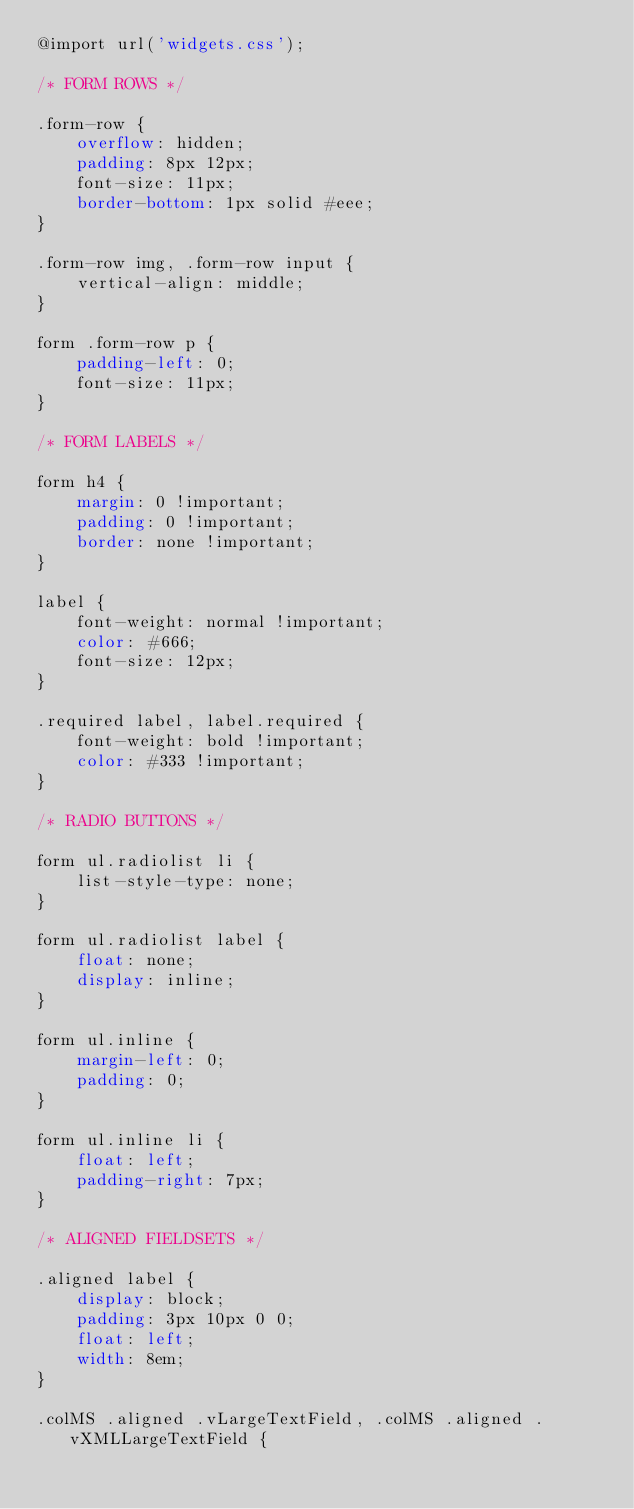Convert code to text. <code><loc_0><loc_0><loc_500><loc_500><_CSS_>@import url('widgets.css');

/* FORM ROWS */

.form-row {
    overflow: hidden;
    padding: 8px 12px;
    font-size: 11px;
    border-bottom: 1px solid #eee;
}

.form-row img, .form-row input {
    vertical-align: middle;
}

form .form-row p {
    padding-left: 0;
    font-size: 11px;
}

/* FORM LABELS */

form h4 {
    margin: 0 !important;
    padding: 0 !important;
    border: none !important;
}

label {
    font-weight: normal !important;
    color: #666;
    font-size: 12px;
}

.required label, label.required {
    font-weight: bold !important;
    color: #333 !important;
}

/* RADIO BUTTONS */

form ul.radiolist li {
    list-style-type: none;
}

form ul.radiolist label {
    float: none;
    display: inline;
}

form ul.inline {
    margin-left: 0;
    padding: 0;
}

form ul.inline li {
    float: left;
    padding-right: 7px;
}

/* ALIGNED FIELDSETS */

.aligned label {
    display: block;
    padding: 3px 10px 0 0;
    float: left;
    width: 8em;
}

.colMS .aligned .vLargeTextField, .colMS .aligned .vXMLLargeTextField {</code> 